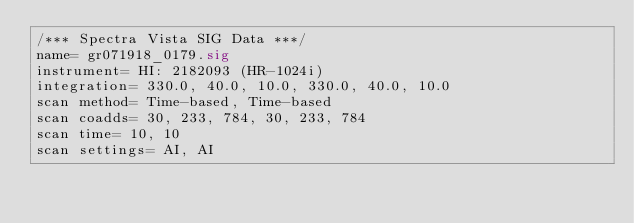<code> <loc_0><loc_0><loc_500><loc_500><_SML_>/*** Spectra Vista SIG Data ***/
name= gr071918_0179.sig
instrument= HI: 2182093 (HR-1024i)
integration= 330.0, 40.0, 10.0, 330.0, 40.0, 10.0
scan method= Time-based, Time-based
scan coadds= 30, 233, 784, 30, 233, 784
scan time= 10, 10
scan settings= AI, AI</code> 